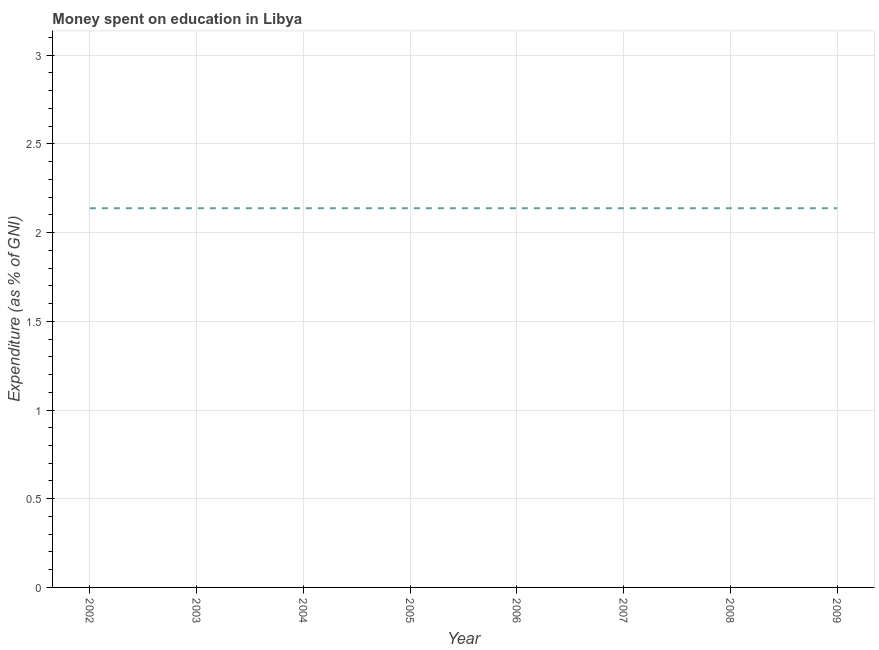What is the expenditure on education in 2002?
Your answer should be very brief. 2.14. Across all years, what is the maximum expenditure on education?
Give a very brief answer. 2.14. Across all years, what is the minimum expenditure on education?
Make the answer very short. 2.14. In which year was the expenditure on education maximum?
Ensure brevity in your answer.  2002. What is the sum of the expenditure on education?
Offer a terse response. 17.1. What is the average expenditure on education per year?
Ensure brevity in your answer.  2.14. What is the median expenditure on education?
Provide a short and direct response. 2.14. What is the ratio of the expenditure on education in 2007 to that in 2008?
Ensure brevity in your answer.  1. Is the expenditure on education in 2002 less than that in 2006?
Keep it short and to the point. No. Is the difference between the expenditure on education in 2007 and 2009 greater than the difference between any two years?
Your answer should be compact. Yes. What is the difference between the highest and the second highest expenditure on education?
Provide a succinct answer. 0. What is the difference between the highest and the lowest expenditure on education?
Your answer should be compact. 0. Does the expenditure on education monotonically increase over the years?
Ensure brevity in your answer.  No. How many years are there in the graph?
Offer a very short reply. 8. Are the values on the major ticks of Y-axis written in scientific E-notation?
Make the answer very short. No. Does the graph contain any zero values?
Your answer should be very brief. No. What is the title of the graph?
Provide a succinct answer. Money spent on education in Libya. What is the label or title of the X-axis?
Your answer should be compact. Year. What is the label or title of the Y-axis?
Provide a succinct answer. Expenditure (as % of GNI). What is the Expenditure (as % of GNI) in 2002?
Offer a terse response. 2.14. What is the Expenditure (as % of GNI) in 2003?
Ensure brevity in your answer.  2.14. What is the Expenditure (as % of GNI) in 2004?
Give a very brief answer. 2.14. What is the Expenditure (as % of GNI) of 2005?
Your answer should be compact. 2.14. What is the Expenditure (as % of GNI) in 2006?
Offer a terse response. 2.14. What is the Expenditure (as % of GNI) of 2007?
Keep it short and to the point. 2.14. What is the Expenditure (as % of GNI) in 2008?
Your response must be concise. 2.14. What is the Expenditure (as % of GNI) of 2009?
Provide a short and direct response. 2.14. What is the difference between the Expenditure (as % of GNI) in 2002 and 2005?
Your answer should be compact. 0. What is the difference between the Expenditure (as % of GNI) in 2002 and 2006?
Your response must be concise. 0. What is the difference between the Expenditure (as % of GNI) in 2002 and 2008?
Provide a succinct answer. 0. What is the difference between the Expenditure (as % of GNI) in 2003 and 2004?
Your response must be concise. 0. What is the difference between the Expenditure (as % of GNI) in 2003 and 2005?
Provide a succinct answer. 0. What is the difference between the Expenditure (as % of GNI) in 2003 and 2006?
Offer a terse response. 0. What is the difference between the Expenditure (as % of GNI) in 2003 and 2009?
Provide a short and direct response. 0. What is the difference between the Expenditure (as % of GNI) in 2004 and 2007?
Offer a very short reply. 0. What is the difference between the Expenditure (as % of GNI) in 2004 and 2008?
Offer a very short reply. 0. What is the difference between the Expenditure (as % of GNI) in 2004 and 2009?
Offer a very short reply. 0. What is the difference between the Expenditure (as % of GNI) in 2005 and 2006?
Provide a succinct answer. 0. What is the difference between the Expenditure (as % of GNI) in 2005 and 2008?
Provide a short and direct response. 0. What is the difference between the Expenditure (as % of GNI) in 2005 and 2009?
Provide a succinct answer. 0. What is the difference between the Expenditure (as % of GNI) in 2006 and 2009?
Your answer should be compact. 0. What is the difference between the Expenditure (as % of GNI) in 2007 and 2008?
Offer a very short reply. 0. What is the difference between the Expenditure (as % of GNI) in 2008 and 2009?
Offer a terse response. 0. What is the ratio of the Expenditure (as % of GNI) in 2002 to that in 2003?
Ensure brevity in your answer.  1. What is the ratio of the Expenditure (as % of GNI) in 2002 to that in 2004?
Ensure brevity in your answer.  1. What is the ratio of the Expenditure (as % of GNI) in 2002 to that in 2005?
Your answer should be very brief. 1. What is the ratio of the Expenditure (as % of GNI) in 2002 to that in 2006?
Provide a succinct answer. 1. What is the ratio of the Expenditure (as % of GNI) in 2002 to that in 2007?
Offer a terse response. 1. What is the ratio of the Expenditure (as % of GNI) in 2002 to that in 2008?
Keep it short and to the point. 1. What is the ratio of the Expenditure (as % of GNI) in 2003 to that in 2004?
Your answer should be compact. 1. What is the ratio of the Expenditure (as % of GNI) in 2003 to that in 2005?
Your answer should be very brief. 1. What is the ratio of the Expenditure (as % of GNI) in 2003 to that in 2008?
Ensure brevity in your answer.  1. What is the ratio of the Expenditure (as % of GNI) in 2003 to that in 2009?
Make the answer very short. 1. What is the ratio of the Expenditure (as % of GNI) in 2004 to that in 2005?
Your response must be concise. 1. What is the ratio of the Expenditure (as % of GNI) in 2004 to that in 2007?
Ensure brevity in your answer.  1. What is the ratio of the Expenditure (as % of GNI) in 2006 to that in 2007?
Your answer should be very brief. 1. What is the ratio of the Expenditure (as % of GNI) in 2006 to that in 2009?
Ensure brevity in your answer.  1. What is the ratio of the Expenditure (as % of GNI) in 2007 to that in 2008?
Provide a short and direct response. 1. What is the ratio of the Expenditure (as % of GNI) in 2008 to that in 2009?
Your response must be concise. 1. 